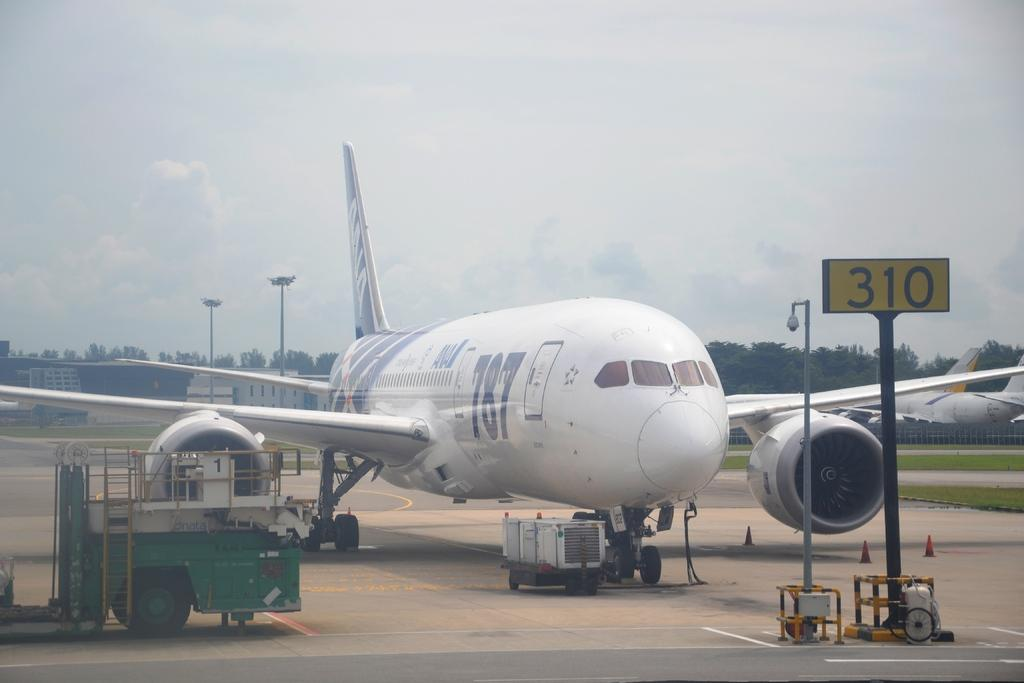What is the main subject of the image? The main subject of the image is an airplane on the runway. What other vehicles can be seen in the image? There are trucks visible in the image. What can be seen in the background of the image? There are trees, sheds, and the sky visible in the background of the image. What type of oil is being used to lubricate the watch in the image? There is no watch present in the image, so it is not possible to determine what type of oil is being used to lubricate it. 